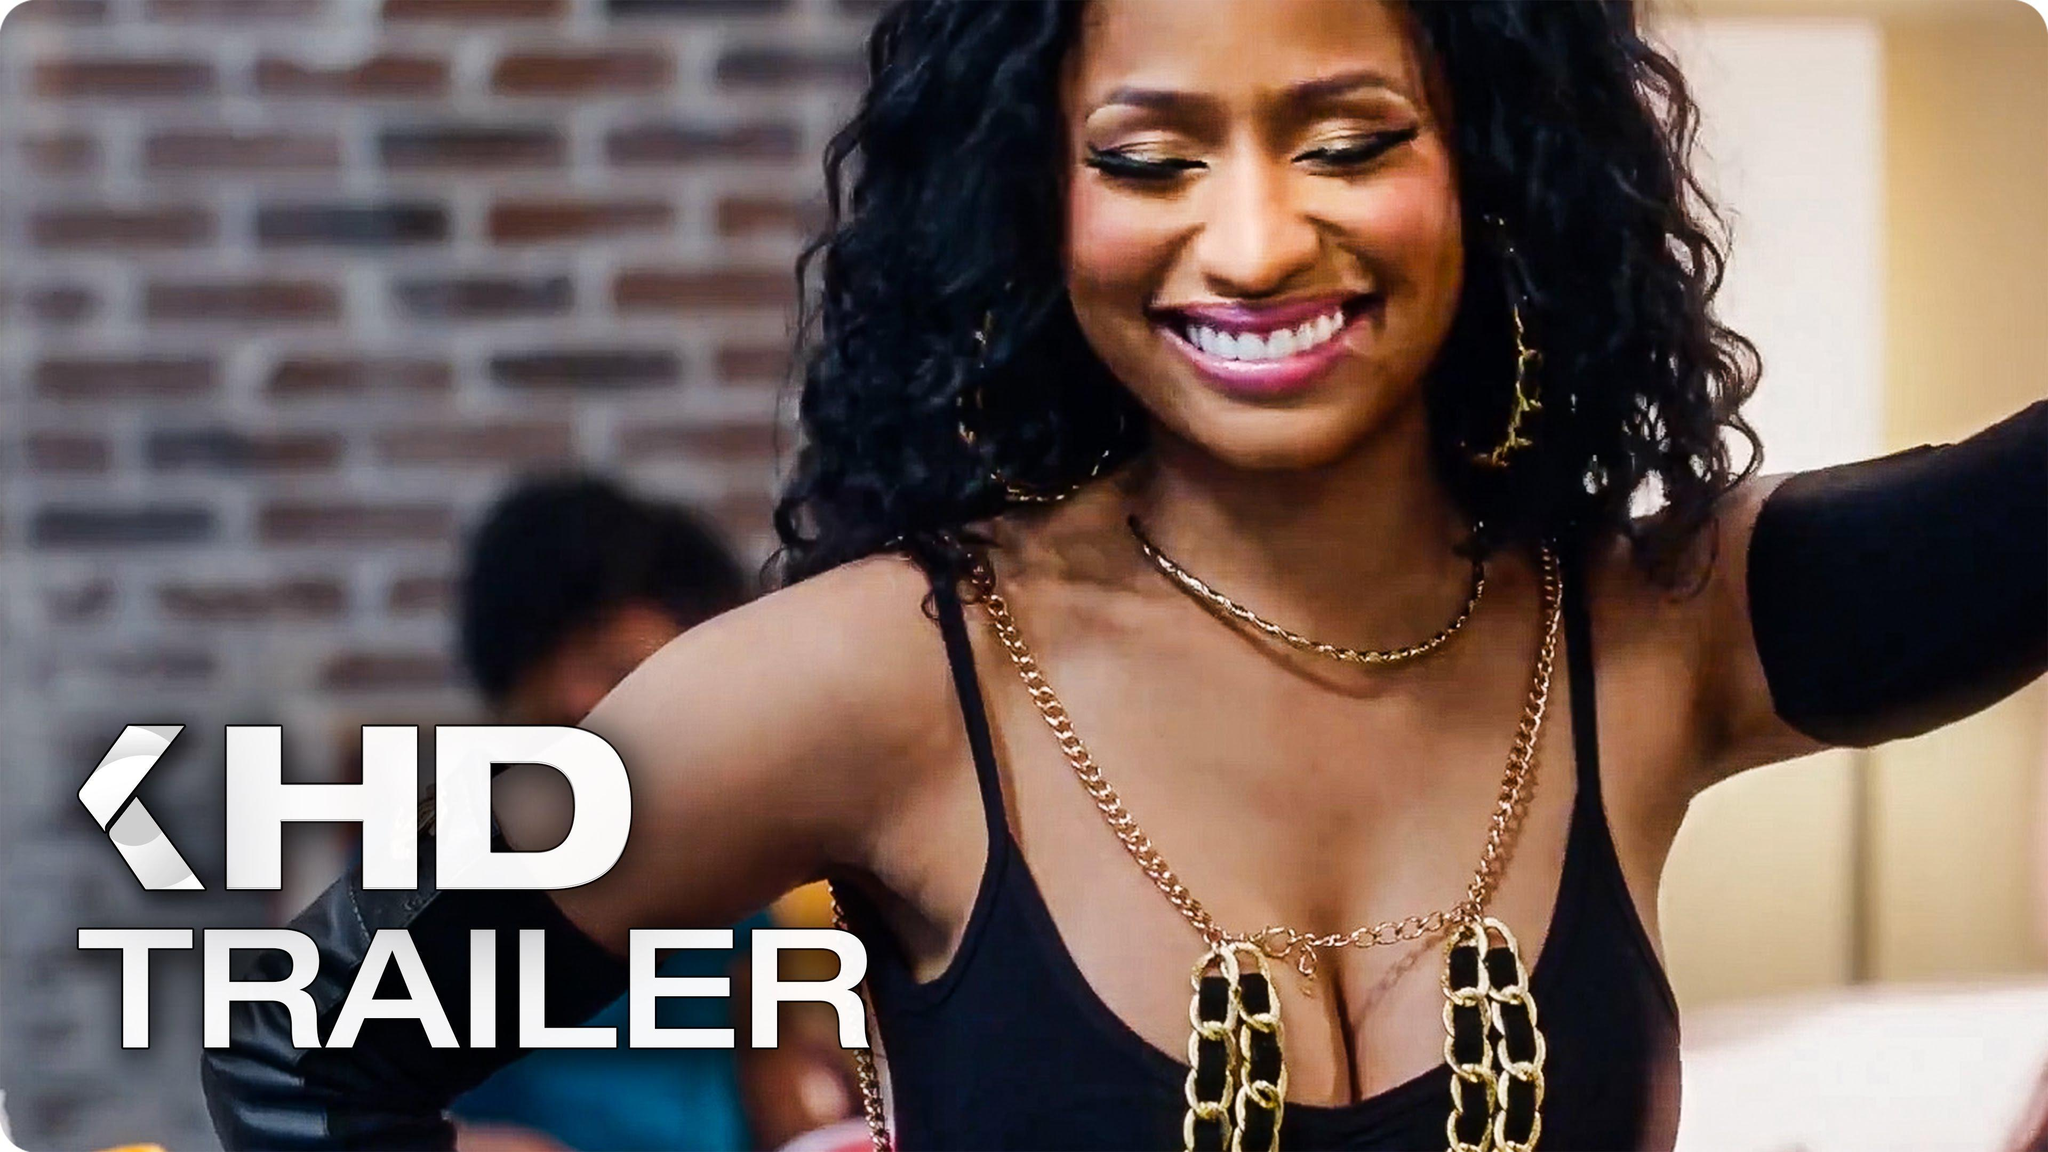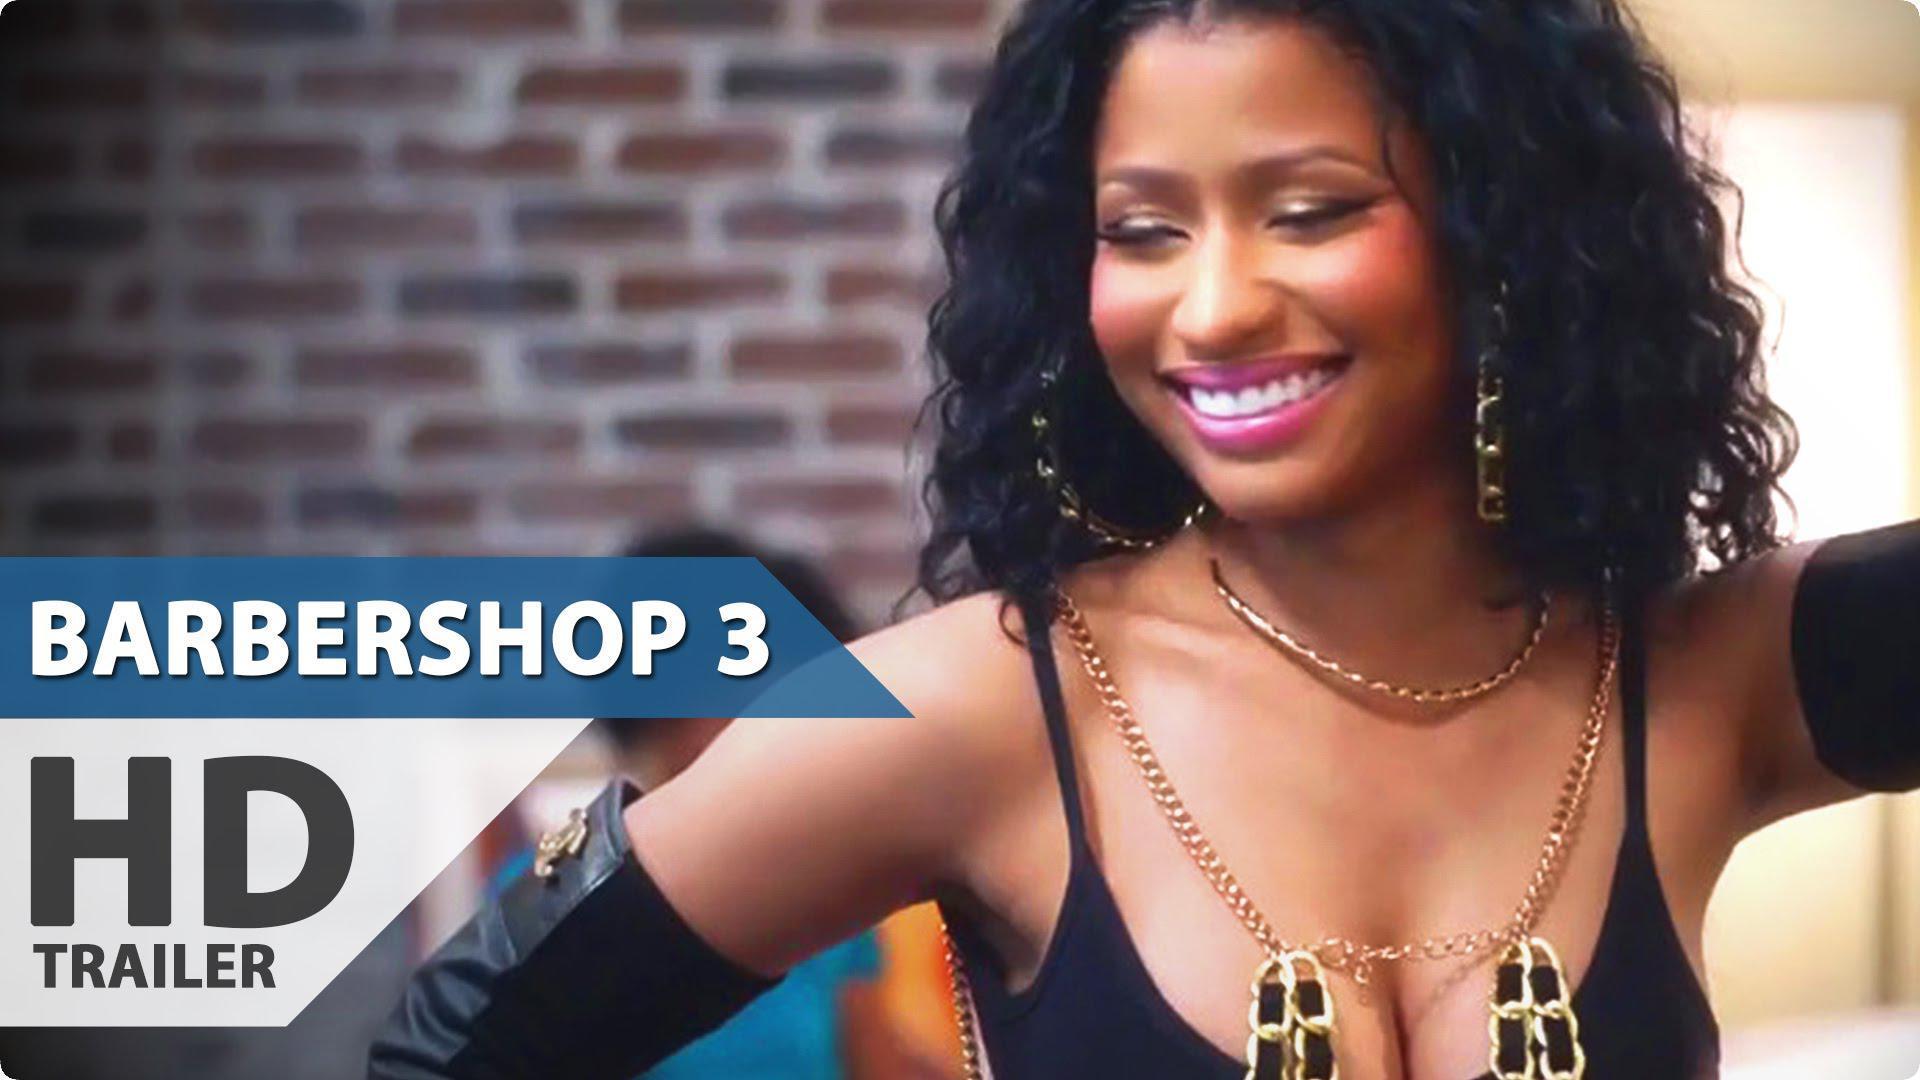The first image is the image on the left, the second image is the image on the right. Given the left and right images, does the statement "One of the images has two different women." hold true? Answer yes or no. No. The first image is the image on the left, the second image is the image on the right. For the images shown, is this caption "She is wearing the same necklace in every single image." true? Answer yes or no. Yes. 